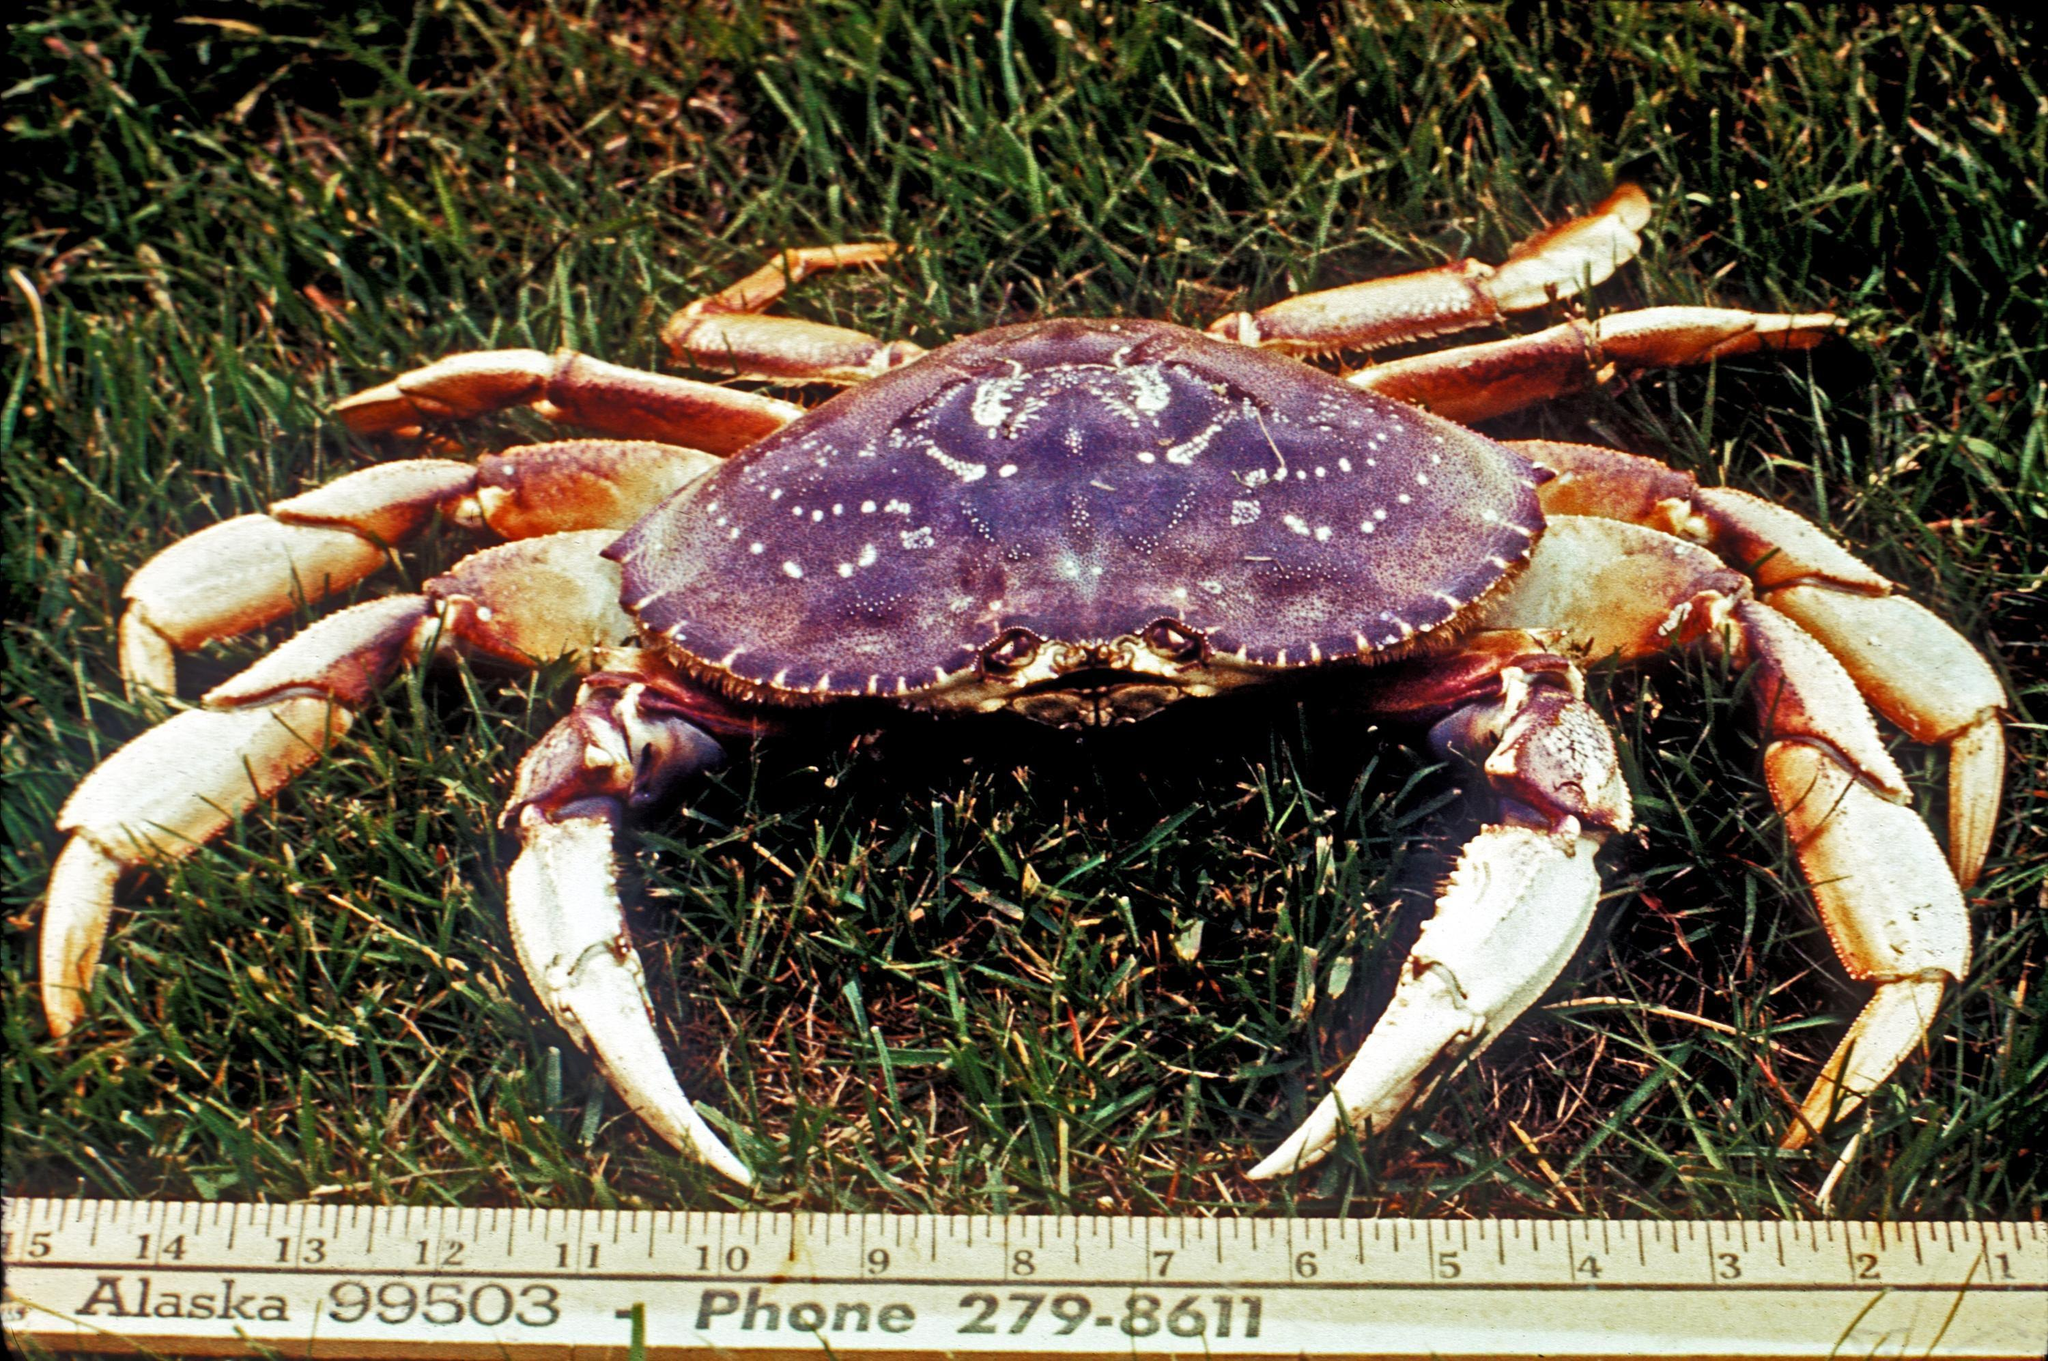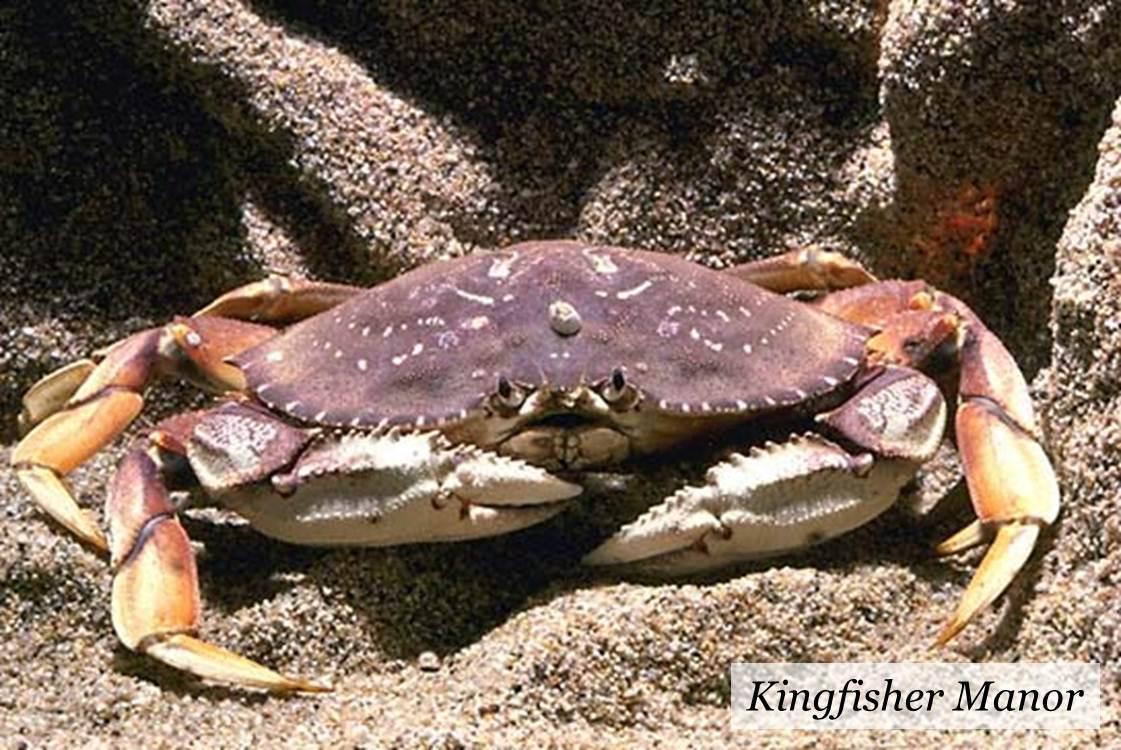The first image is the image on the left, the second image is the image on the right. Evaluate the accuracy of this statement regarding the images: "there are two crabs in the image pair". Is it true? Answer yes or no. Yes. 